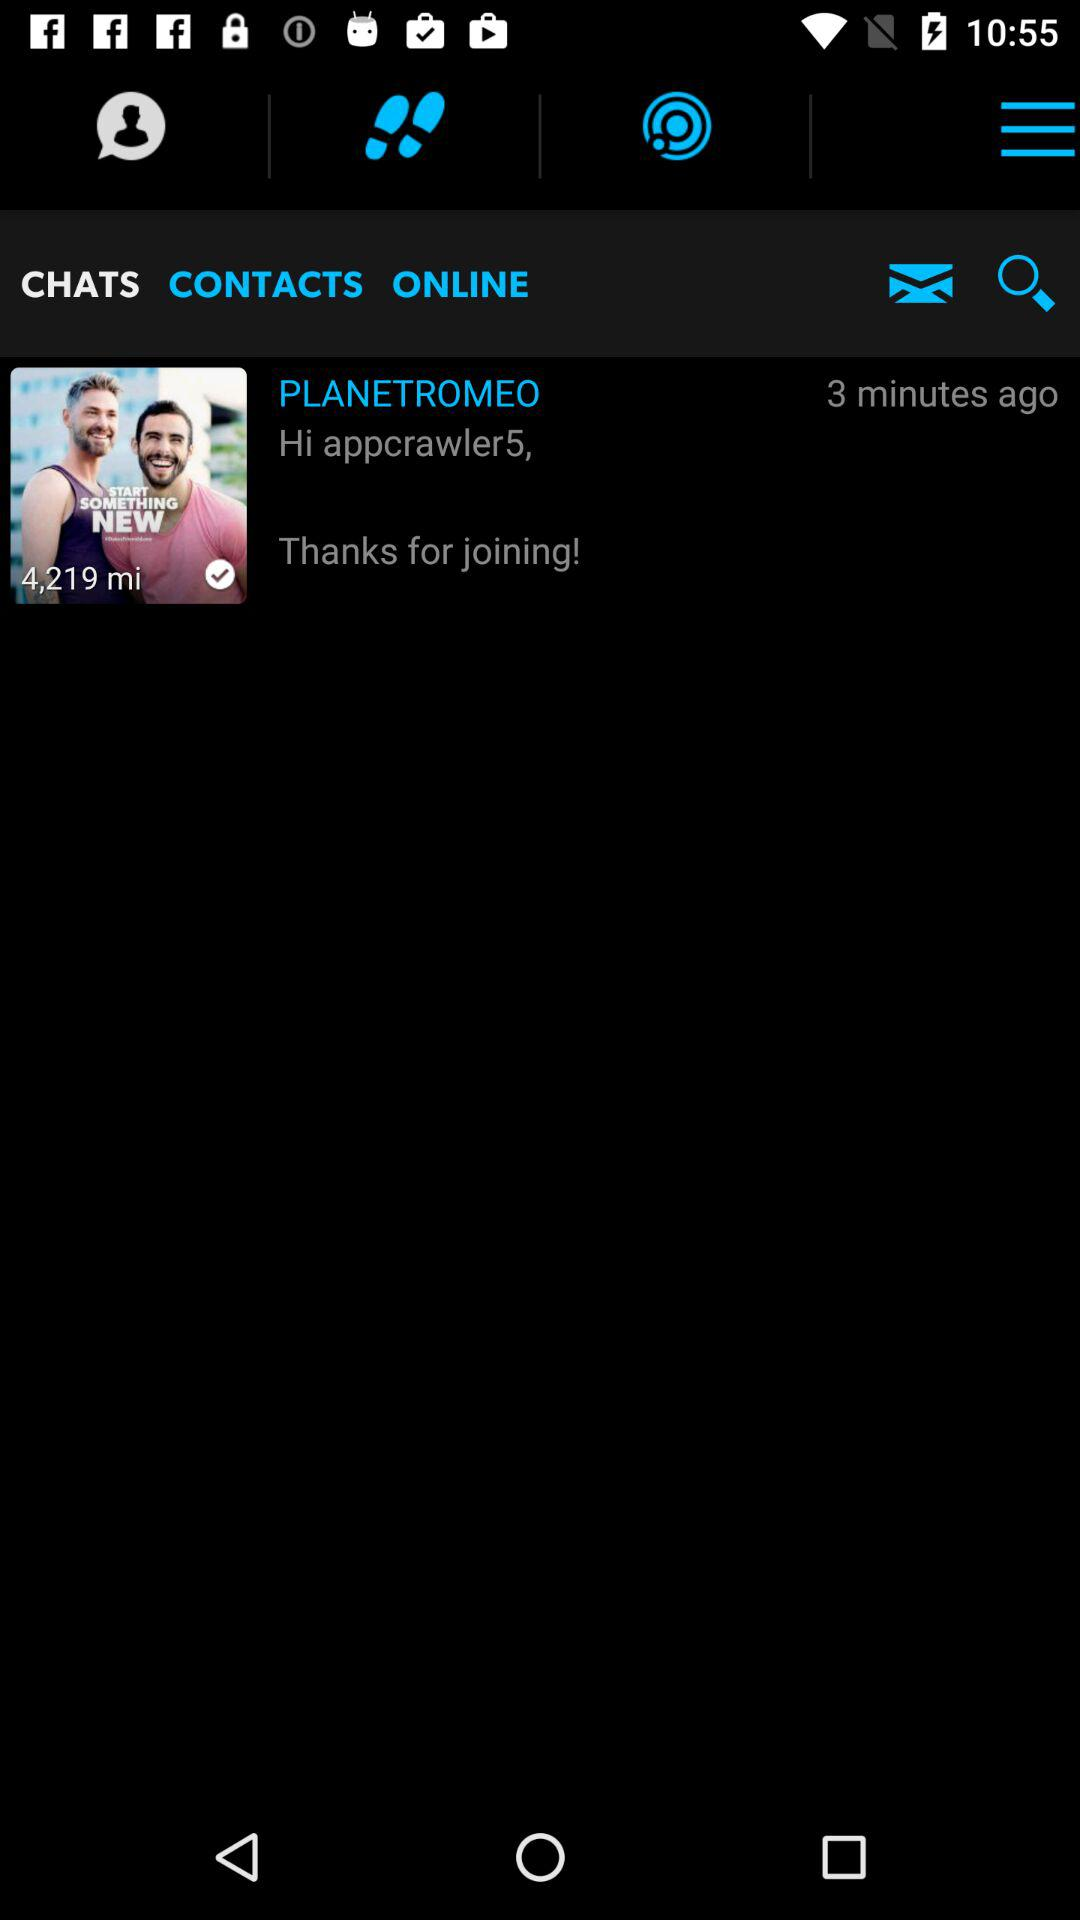Whose message is shown on the screen? The message shown on the screen is from "PLANETROMEO". 